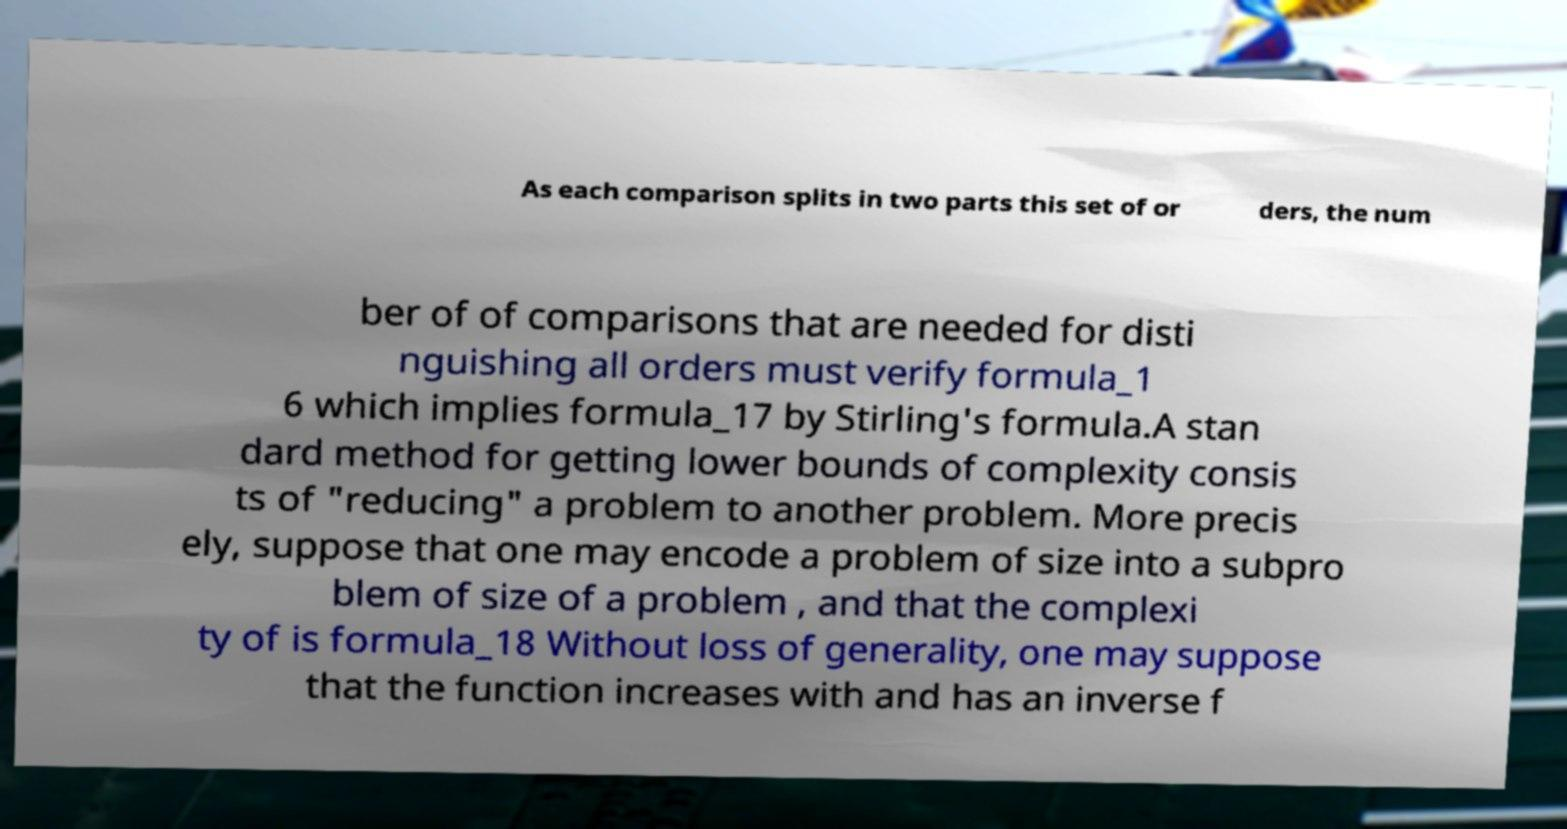Please identify and transcribe the text found in this image. As each comparison splits in two parts this set of or ders, the num ber of of comparisons that are needed for disti nguishing all orders must verify formula_1 6 which implies formula_17 by Stirling's formula.A stan dard method for getting lower bounds of complexity consis ts of "reducing" a problem to another problem. More precis ely, suppose that one may encode a problem of size into a subpro blem of size of a problem , and that the complexi ty of is formula_18 Without loss of generality, one may suppose that the function increases with and has an inverse f 